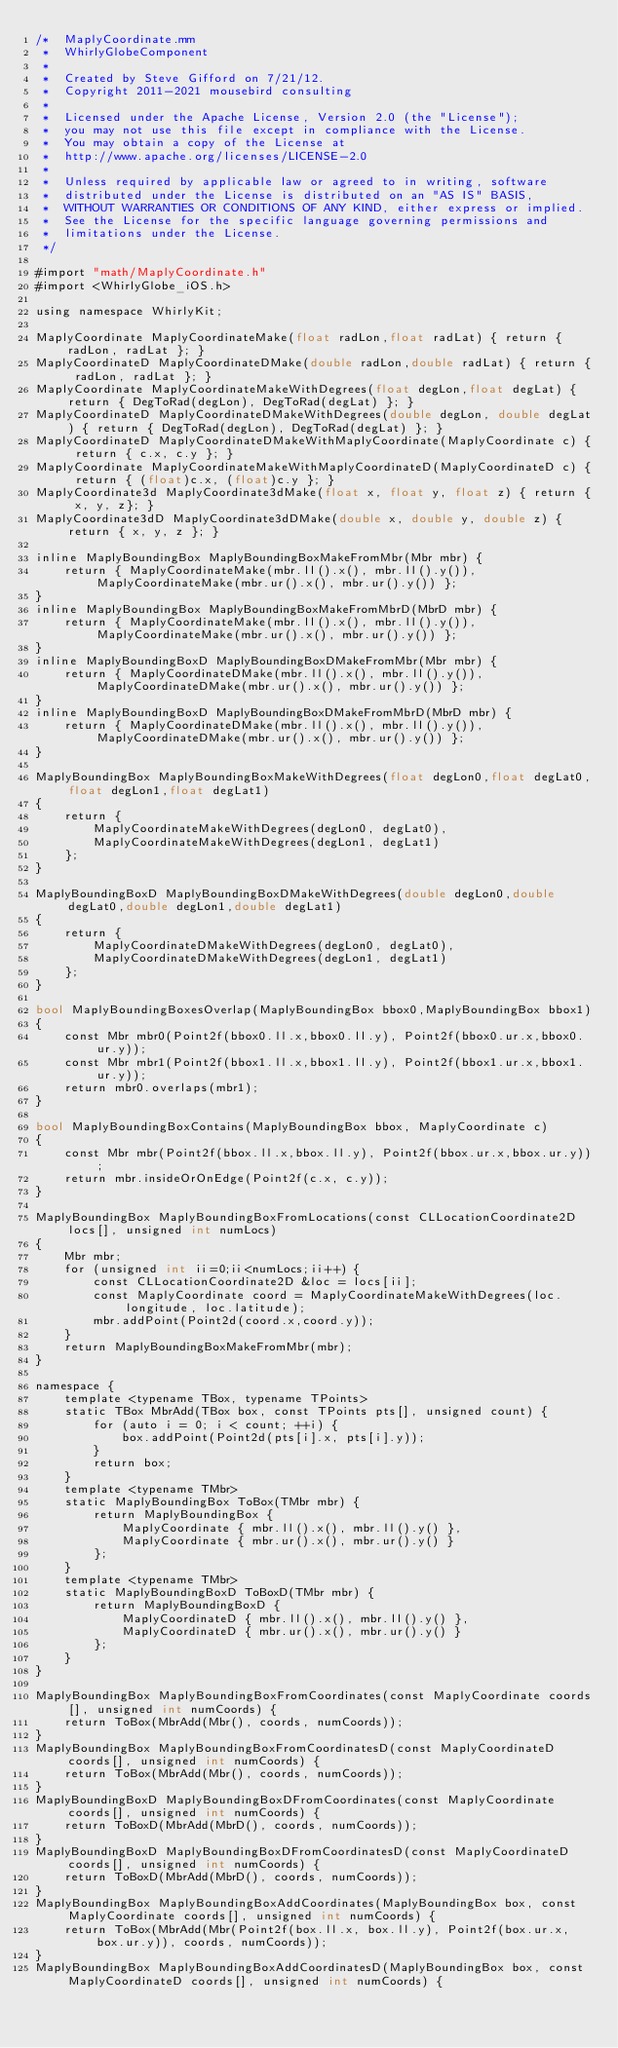Convert code to text. <code><loc_0><loc_0><loc_500><loc_500><_ObjectiveC_>/*  MaplyCoordinate.mm
 *  WhirlyGlobeComponent
 *
 *  Created by Steve Gifford on 7/21/12.
 *  Copyright 2011-2021 mousebird consulting
 *
 *  Licensed under the Apache License, Version 2.0 (the "License");
 *  you may not use this file except in compliance with the License.
 *  You may obtain a copy of the License at
 *  http://www.apache.org/licenses/LICENSE-2.0
 *
 *  Unless required by applicable law or agreed to in writing, software
 *  distributed under the License is distributed on an "AS IS" BASIS,
 *  WITHOUT WARRANTIES OR CONDITIONS OF ANY KIND, either express or implied.
 *  See the License for the specific language governing permissions and
 *  limitations under the License.
 */

#import "math/MaplyCoordinate.h"
#import <WhirlyGlobe_iOS.h>

using namespace WhirlyKit;

MaplyCoordinate MaplyCoordinateMake(float radLon,float radLat) { return { radLon, radLat }; }
MaplyCoordinateD MaplyCoordinateDMake(double radLon,double radLat) { return { radLon, radLat }; }
MaplyCoordinate MaplyCoordinateMakeWithDegrees(float degLon,float degLat) { return { DegToRad(degLon), DegToRad(degLat) }; }
MaplyCoordinateD MaplyCoordinateDMakeWithDegrees(double degLon, double degLat) { return { DegToRad(degLon), DegToRad(degLat) }; }
MaplyCoordinateD MaplyCoordinateDMakeWithMaplyCoordinate(MaplyCoordinate c) { return { c.x, c.y }; }
MaplyCoordinate MaplyCoordinateMakeWithMaplyCoordinateD(MaplyCoordinateD c) { return { (float)c.x, (float)c.y }; }
MaplyCoordinate3d MaplyCoordinate3dMake(float x, float y, float z) { return { x, y, z}; }
MaplyCoordinate3dD MaplyCoordinate3dDMake(double x, double y, double z) { return { x, y, z }; }

inline MaplyBoundingBox MaplyBoundingBoxMakeFromMbr(Mbr mbr) {
    return { MaplyCoordinateMake(mbr.ll().x(), mbr.ll().y()), MaplyCoordinateMake(mbr.ur().x(), mbr.ur().y()) };
}
inline MaplyBoundingBox MaplyBoundingBoxMakeFromMbrD(MbrD mbr) {
    return { MaplyCoordinateMake(mbr.ll().x(), mbr.ll().y()), MaplyCoordinateMake(mbr.ur().x(), mbr.ur().y()) };
}
inline MaplyBoundingBoxD MaplyBoundingBoxDMakeFromMbr(Mbr mbr) {
    return { MaplyCoordinateDMake(mbr.ll().x(), mbr.ll().y()), MaplyCoordinateDMake(mbr.ur().x(), mbr.ur().y()) };
}
inline MaplyBoundingBoxD MaplyBoundingBoxDMakeFromMbrD(MbrD mbr) {
    return { MaplyCoordinateDMake(mbr.ll().x(), mbr.ll().y()), MaplyCoordinateDMake(mbr.ur().x(), mbr.ur().y()) };
}

MaplyBoundingBox MaplyBoundingBoxMakeWithDegrees(float degLon0,float degLat0,float degLon1,float degLat1)
{
    return {
        MaplyCoordinateMakeWithDegrees(degLon0, degLat0),
        MaplyCoordinateMakeWithDegrees(degLon1, degLat1)
    };
}

MaplyBoundingBoxD MaplyBoundingBoxDMakeWithDegrees(double degLon0,double degLat0,double degLon1,double degLat1)
{
    return {
        MaplyCoordinateDMakeWithDegrees(degLon0, degLat0),
        MaplyCoordinateDMakeWithDegrees(degLon1, degLat1)
    };
}

bool MaplyBoundingBoxesOverlap(MaplyBoundingBox bbox0,MaplyBoundingBox bbox1)
{
    const Mbr mbr0(Point2f(bbox0.ll.x,bbox0.ll.y), Point2f(bbox0.ur.x,bbox0.ur.y));
    const Mbr mbr1(Point2f(bbox1.ll.x,bbox1.ll.y), Point2f(bbox1.ur.x,bbox1.ur.y));
    return mbr0.overlaps(mbr1);
}

bool MaplyBoundingBoxContains(MaplyBoundingBox bbox, MaplyCoordinate c)
{
    const Mbr mbr(Point2f(bbox.ll.x,bbox.ll.y), Point2f(bbox.ur.x,bbox.ur.y));
    return mbr.insideOrOnEdge(Point2f(c.x, c.y));
}

MaplyBoundingBox MaplyBoundingBoxFromLocations(const CLLocationCoordinate2D locs[], unsigned int numLocs)
{
    Mbr mbr;
    for (unsigned int ii=0;ii<numLocs;ii++) {
        const CLLocationCoordinate2D &loc = locs[ii];
        const MaplyCoordinate coord = MaplyCoordinateMakeWithDegrees(loc.longitude, loc.latitude);
        mbr.addPoint(Point2d(coord.x,coord.y));
    }
    return MaplyBoundingBoxMakeFromMbr(mbr);
}

namespace {
    template <typename TBox, typename TPoints>
    static TBox MbrAdd(TBox box, const TPoints pts[], unsigned count) {
        for (auto i = 0; i < count; ++i) {
            box.addPoint(Point2d(pts[i].x, pts[i].y));
        }
        return box;
    }
    template <typename TMbr>
    static MaplyBoundingBox ToBox(TMbr mbr) {
        return MaplyBoundingBox {
            MaplyCoordinate { mbr.ll().x(), mbr.ll().y() },
            MaplyCoordinate { mbr.ur().x(), mbr.ur().y() }
        };
    }
    template <typename TMbr>
    static MaplyBoundingBoxD ToBoxD(TMbr mbr) {
        return MaplyBoundingBoxD {
            MaplyCoordinateD { mbr.ll().x(), mbr.ll().y() },
            MaplyCoordinateD { mbr.ur().x(), mbr.ur().y() }
        };
    }
}

MaplyBoundingBox MaplyBoundingBoxFromCoordinates(const MaplyCoordinate coords[], unsigned int numCoords) {
    return ToBox(MbrAdd(Mbr(), coords, numCoords));
}
MaplyBoundingBox MaplyBoundingBoxFromCoordinatesD(const MaplyCoordinateD coords[], unsigned int numCoords) {
    return ToBox(MbrAdd(Mbr(), coords, numCoords));
}
MaplyBoundingBoxD MaplyBoundingBoxDFromCoordinates(const MaplyCoordinate coords[], unsigned int numCoords) {
    return ToBoxD(MbrAdd(MbrD(), coords, numCoords));
}
MaplyBoundingBoxD MaplyBoundingBoxDFromCoordinatesD(const MaplyCoordinateD coords[], unsigned int numCoords) {
    return ToBoxD(MbrAdd(MbrD(), coords, numCoords));
}
MaplyBoundingBox MaplyBoundingBoxAddCoordinates(MaplyBoundingBox box, const MaplyCoordinate coords[], unsigned int numCoords) {
    return ToBox(MbrAdd(Mbr(Point2f(box.ll.x, box.ll.y), Point2f(box.ur.x, box.ur.y)), coords, numCoords));
}
MaplyBoundingBox MaplyBoundingBoxAddCoordinatesD(MaplyBoundingBox box, const MaplyCoordinateD coords[], unsigned int numCoords) {</code> 